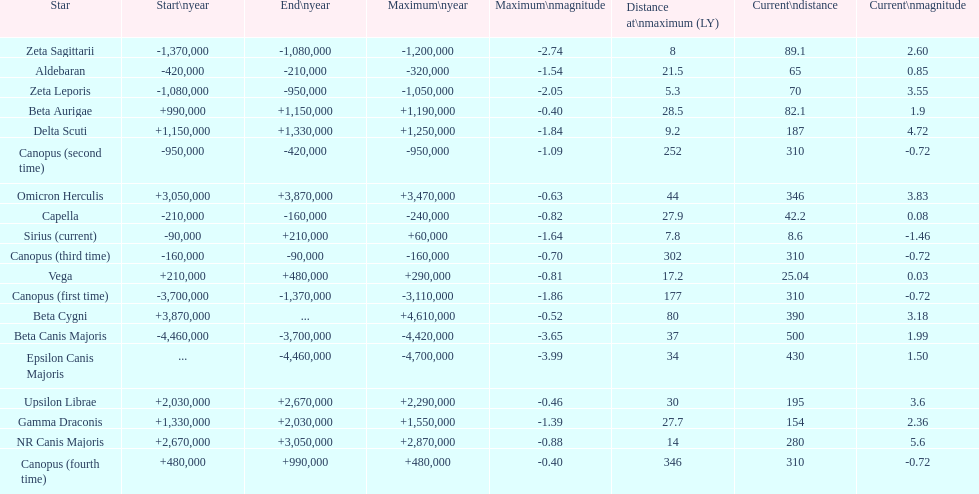Is capella's current magnitude more than vega's current magnitude? Yes. 